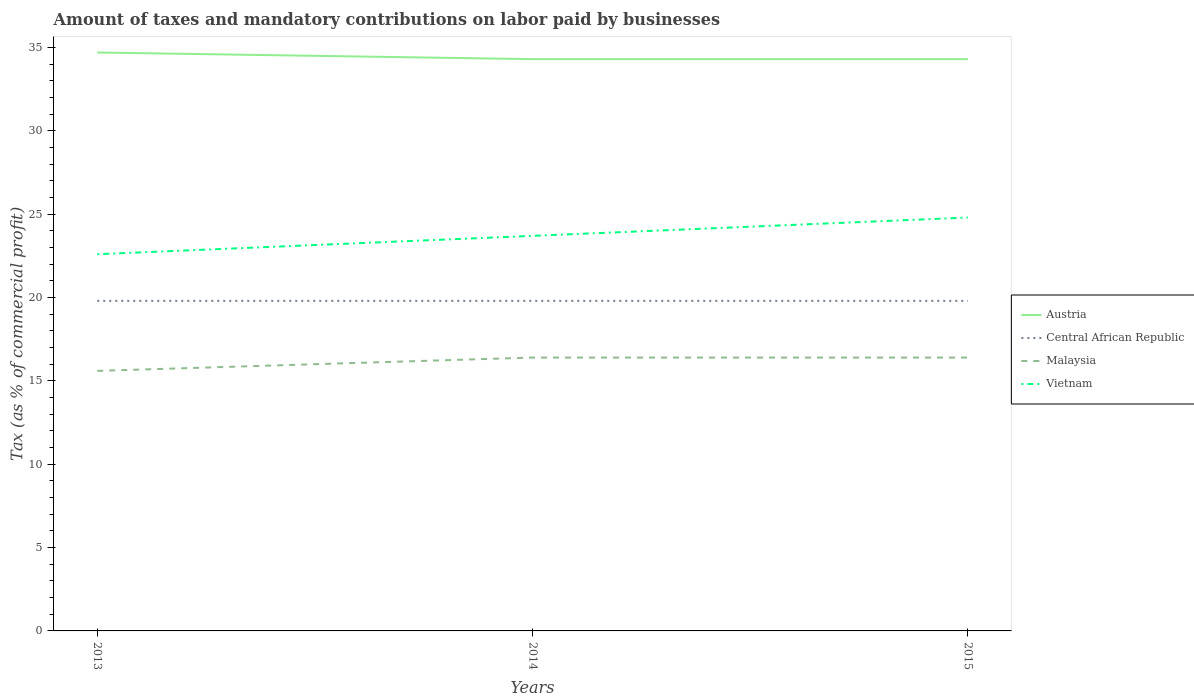How many different coloured lines are there?
Give a very brief answer. 4. Across all years, what is the maximum percentage of taxes paid by businesses in Austria?
Provide a short and direct response. 34.3. What is the total percentage of taxes paid by businesses in Malaysia in the graph?
Make the answer very short. -0.8. What is the difference between the highest and the second highest percentage of taxes paid by businesses in Vietnam?
Make the answer very short. 2.2. How many lines are there?
Provide a short and direct response. 4. How many years are there in the graph?
Make the answer very short. 3. Does the graph contain any zero values?
Make the answer very short. No. Where does the legend appear in the graph?
Give a very brief answer. Center right. How many legend labels are there?
Ensure brevity in your answer.  4. How are the legend labels stacked?
Keep it short and to the point. Vertical. What is the title of the graph?
Your response must be concise. Amount of taxes and mandatory contributions on labor paid by businesses. Does "Dominican Republic" appear as one of the legend labels in the graph?
Your answer should be very brief. No. What is the label or title of the X-axis?
Offer a very short reply. Years. What is the label or title of the Y-axis?
Offer a very short reply. Tax (as % of commercial profit). What is the Tax (as % of commercial profit) of Austria in 2013?
Offer a terse response. 34.7. What is the Tax (as % of commercial profit) of Central African Republic in 2013?
Provide a short and direct response. 19.8. What is the Tax (as % of commercial profit) of Vietnam in 2013?
Keep it short and to the point. 22.6. What is the Tax (as % of commercial profit) in Austria in 2014?
Your answer should be compact. 34.3. What is the Tax (as % of commercial profit) of Central African Republic in 2014?
Provide a short and direct response. 19.8. What is the Tax (as % of commercial profit) of Malaysia in 2014?
Ensure brevity in your answer.  16.4. What is the Tax (as % of commercial profit) in Vietnam in 2014?
Your response must be concise. 23.7. What is the Tax (as % of commercial profit) of Austria in 2015?
Make the answer very short. 34.3. What is the Tax (as % of commercial profit) in Central African Republic in 2015?
Your response must be concise. 19.8. What is the Tax (as % of commercial profit) of Malaysia in 2015?
Your answer should be very brief. 16.4. What is the Tax (as % of commercial profit) of Vietnam in 2015?
Ensure brevity in your answer.  24.8. Across all years, what is the maximum Tax (as % of commercial profit) in Austria?
Provide a succinct answer. 34.7. Across all years, what is the maximum Tax (as % of commercial profit) of Central African Republic?
Provide a succinct answer. 19.8. Across all years, what is the maximum Tax (as % of commercial profit) of Malaysia?
Provide a short and direct response. 16.4. Across all years, what is the maximum Tax (as % of commercial profit) in Vietnam?
Offer a terse response. 24.8. Across all years, what is the minimum Tax (as % of commercial profit) in Austria?
Offer a very short reply. 34.3. Across all years, what is the minimum Tax (as % of commercial profit) of Central African Republic?
Your answer should be compact. 19.8. Across all years, what is the minimum Tax (as % of commercial profit) in Malaysia?
Ensure brevity in your answer.  15.6. Across all years, what is the minimum Tax (as % of commercial profit) of Vietnam?
Provide a short and direct response. 22.6. What is the total Tax (as % of commercial profit) in Austria in the graph?
Your answer should be very brief. 103.3. What is the total Tax (as % of commercial profit) of Central African Republic in the graph?
Provide a succinct answer. 59.4. What is the total Tax (as % of commercial profit) of Malaysia in the graph?
Make the answer very short. 48.4. What is the total Tax (as % of commercial profit) in Vietnam in the graph?
Offer a terse response. 71.1. What is the difference between the Tax (as % of commercial profit) in Austria in 2013 and that in 2014?
Provide a succinct answer. 0.4. What is the difference between the Tax (as % of commercial profit) in Central African Republic in 2013 and that in 2014?
Give a very brief answer. 0. What is the difference between the Tax (as % of commercial profit) in Malaysia in 2013 and that in 2014?
Offer a terse response. -0.8. What is the difference between the Tax (as % of commercial profit) of Austria in 2013 and that in 2015?
Give a very brief answer. 0.4. What is the difference between the Tax (as % of commercial profit) in Central African Republic in 2013 and that in 2015?
Your answer should be compact. 0. What is the difference between the Tax (as % of commercial profit) in Malaysia in 2013 and that in 2015?
Your response must be concise. -0.8. What is the difference between the Tax (as % of commercial profit) in Central African Republic in 2014 and that in 2015?
Ensure brevity in your answer.  0. What is the difference between the Tax (as % of commercial profit) of Austria in 2013 and the Tax (as % of commercial profit) of Malaysia in 2014?
Your answer should be very brief. 18.3. What is the difference between the Tax (as % of commercial profit) in Austria in 2013 and the Tax (as % of commercial profit) in Vietnam in 2014?
Ensure brevity in your answer.  11. What is the difference between the Tax (as % of commercial profit) of Malaysia in 2013 and the Tax (as % of commercial profit) of Vietnam in 2014?
Ensure brevity in your answer.  -8.1. What is the difference between the Tax (as % of commercial profit) in Austria in 2013 and the Tax (as % of commercial profit) in Central African Republic in 2015?
Make the answer very short. 14.9. What is the difference between the Tax (as % of commercial profit) in Austria in 2013 and the Tax (as % of commercial profit) in Malaysia in 2015?
Offer a very short reply. 18.3. What is the difference between the Tax (as % of commercial profit) in Austria in 2013 and the Tax (as % of commercial profit) in Vietnam in 2015?
Offer a very short reply. 9.9. What is the difference between the Tax (as % of commercial profit) in Austria in 2014 and the Tax (as % of commercial profit) in Central African Republic in 2015?
Provide a short and direct response. 14.5. What is the difference between the Tax (as % of commercial profit) in Central African Republic in 2014 and the Tax (as % of commercial profit) in Malaysia in 2015?
Your response must be concise. 3.4. What is the difference between the Tax (as % of commercial profit) of Malaysia in 2014 and the Tax (as % of commercial profit) of Vietnam in 2015?
Give a very brief answer. -8.4. What is the average Tax (as % of commercial profit) of Austria per year?
Offer a terse response. 34.43. What is the average Tax (as % of commercial profit) in Central African Republic per year?
Your answer should be very brief. 19.8. What is the average Tax (as % of commercial profit) in Malaysia per year?
Give a very brief answer. 16.13. What is the average Tax (as % of commercial profit) of Vietnam per year?
Give a very brief answer. 23.7. In the year 2013, what is the difference between the Tax (as % of commercial profit) in Austria and Tax (as % of commercial profit) in Vietnam?
Your answer should be very brief. 12.1. In the year 2013, what is the difference between the Tax (as % of commercial profit) in Central African Republic and Tax (as % of commercial profit) in Vietnam?
Offer a terse response. -2.8. In the year 2014, what is the difference between the Tax (as % of commercial profit) of Austria and Tax (as % of commercial profit) of Central African Republic?
Your response must be concise. 14.5. In the year 2014, what is the difference between the Tax (as % of commercial profit) of Austria and Tax (as % of commercial profit) of Malaysia?
Keep it short and to the point. 17.9. In the year 2014, what is the difference between the Tax (as % of commercial profit) in Austria and Tax (as % of commercial profit) in Vietnam?
Provide a short and direct response. 10.6. In the year 2014, what is the difference between the Tax (as % of commercial profit) of Central African Republic and Tax (as % of commercial profit) of Malaysia?
Ensure brevity in your answer.  3.4. In the year 2014, what is the difference between the Tax (as % of commercial profit) in Central African Republic and Tax (as % of commercial profit) in Vietnam?
Make the answer very short. -3.9. In the year 2015, what is the difference between the Tax (as % of commercial profit) of Austria and Tax (as % of commercial profit) of Central African Republic?
Your response must be concise. 14.5. In the year 2015, what is the difference between the Tax (as % of commercial profit) of Central African Republic and Tax (as % of commercial profit) of Vietnam?
Keep it short and to the point. -5. In the year 2015, what is the difference between the Tax (as % of commercial profit) in Malaysia and Tax (as % of commercial profit) in Vietnam?
Give a very brief answer. -8.4. What is the ratio of the Tax (as % of commercial profit) of Austria in 2013 to that in 2014?
Provide a short and direct response. 1.01. What is the ratio of the Tax (as % of commercial profit) in Malaysia in 2013 to that in 2014?
Your answer should be very brief. 0.95. What is the ratio of the Tax (as % of commercial profit) in Vietnam in 2013 to that in 2014?
Provide a short and direct response. 0.95. What is the ratio of the Tax (as % of commercial profit) of Austria in 2013 to that in 2015?
Offer a terse response. 1.01. What is the ratio of the Tax (as % of commercial profit) of Malaysia in 2013 to that in 2015?
Your answer should be very brief. 0.95. What is the ratio of the Tax (as % of commercial profit) in Vietnam in 2013 to that in 2015?
Keep it short and to the point. 0.91. What is the ratio of the Tax (as % of commercial profit) of Vietnam in 2014 to that in 2015?
Your answer should be compact. 0.96. What is the difference between the highest and the second highest Tax (as % of commercial profit) in Central African Republic?
Your answer should be very brief. 0. What is the difference between the highest and the lowest Tax (as % of commercial profit) of Central African Republic?
Offer a terse response. 0. 